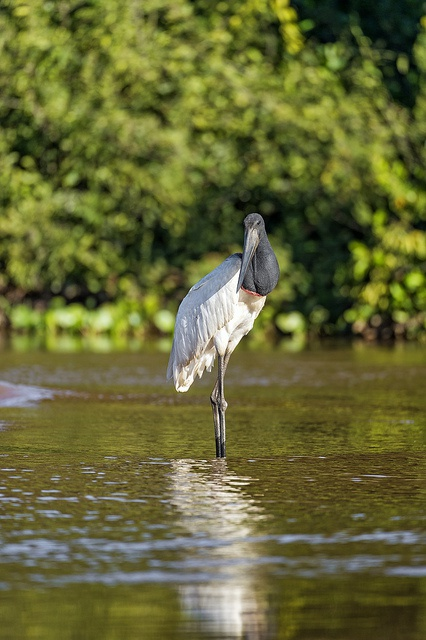Describe the objects in this image and their specific colors. I can see a bird in darkgreen, darkgray, lightgray, gray, and black tones in this image. 